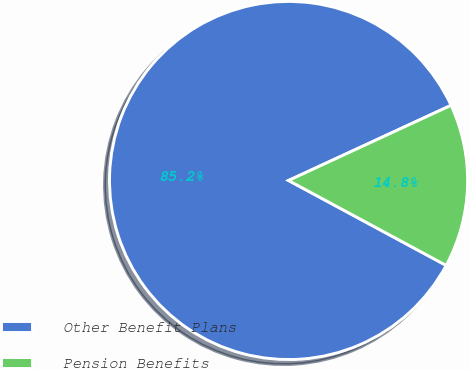Convert chart. <chart><loc_0><loc_0><loc_500><loc_500><pie_chart><fcel>Other Benefit Plans<fcel>Pension Benefits<nl><fcel>85.24%<fcel>14.76%<nl></chart> 